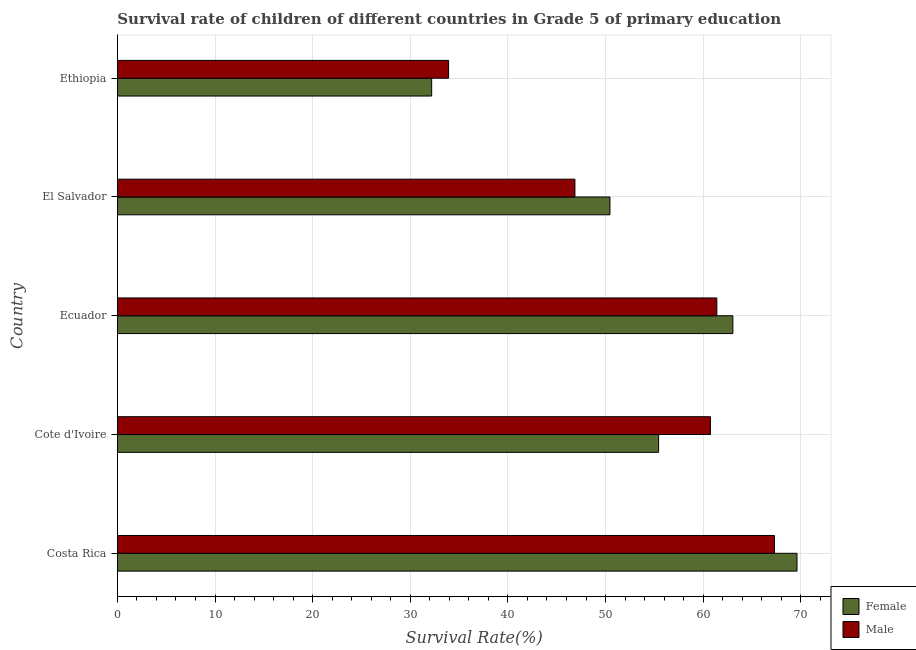How many groups of bars are there?
Provide a short and direct response. 5. How many bars are there on the 5th tick from the bottom?
Offer a very short reply. 2. What is the label of the 5th group of bars from the top?
Make the answer very short. Costa Rica. What is the survival rate of female students in primary education in Ecuador?
Make the answer very short. 63.04. Across all countries, what is the maximum survival rate of female students in primary education?
Provide a short and direct response. 69.61. Across all countries, what is the minimum survival rate of female students in primary education?
Make the answer very short. 32.19. In which country was the survival rate of male students in primary education minimum?
Offer a very short reply. Ethiopia. What is the total survival rate of male students in primary education in the graph?
Offer a terse response. 270.22. What is the difference between the survival rate of female students in primary education in Costa Rica and that in Ecuador?
Your answer should be compact. 6.57. What is the difference between the survival rate of male students in primary education in Ethiopia and the survival rate of female students in primary education in Cote d'Ivoire?
Your answer should be compact. -21.51. What is the average survival rate of male students in primary education per country?
Ensure brevity in your answer.  54.04. What is the difference between the survival rate of female students in primary education and survival rate of male students in primary education in Cote d'Ivoire?
Offer a terse response. -5.31. In how many countries, is the survival rate of male students in primary education greater than 28 %?
Offer a very short reply. 5. What is the ratio of the survival rate of male students in primary education in Ecuador to that in El Salvador?
Ensure brevity in your answer.  1.31. What is the difference between the highest and the second highest survival rate of male students in primary education?
Make the answer very short. 5.91. What is the difference between the highest and the lowest survival rate of male students in primary education?
Your answer should be compact. 33.38. In how many countries, is the survival rate of female students in primary education greater than the average survival rate of female students in primary education taken over all countries?
Make the answer very short. 3. Is the sum of the survival rate of female students in primary education in Cote d'Ivoire and El Salvador greater than the maximum survival rate of male students in primary education across all countries?
Give a very brief answer. Yes. What does the 2nd bar from the top in Ethiopia represents?
Ensure brevity in your answer.  Female. What does the 2nd bar from the bottom in Costa Rica represents?
Offer a very short reply. Male. How many bars are there?
Ensure brevity in your answer.  10. Are all the bars in the graph horizontal?
Provide a short and direct response. Yes. How many countries are there in the graph?
Provide a short and direct response. 5. Does the graph contain any zero values?
Provide a short and direct response. No. Does the graph contain grids?
Keep it short and to the point. Yes. How many legend labels are there?
Your answer should be very brief. 2. What is the title of the graph?
Your answer should be compact. Survival rate of children of different countries in Grade 5 of primary education. What is the label or title of the X-axis?
Provide a succinct answer. Survival Rate(%). What is the Survival Rate(%) in Female in Costa Rica?
Ensure brevity in your answer.  69.61. What is the Survival Rate(%) in Male in Costa Rica?
Make the answer very short. 67.3. What is the Survival Rate(%) of Female in Cote d'Ivoire?
Give a very brief answer. 55.43. What is the Survival Rate(%) in Male in Cote d'Ivoire?
Provide a short and direct response. 60.74. What is the Survival Rate(%) in Female in Ecuador?
Ensure brevity in your answer.  63.04. What is the Survival Rate(%) in Male in Ecuador?
Your response must be concise. 61.39. What is the Survival Rate(%) in Female in El Salvador?
Make the answer very short. 50.45. What is the Survival Rate(%) of Male in El Salvador?
Your response must be concise. 46.86. What is the Survival Rate(%) in Female in Ethiopia?
Keep it short and to the point. 32.19. What is the Survival Rate(%) in Male in Ethiopia?
Your answer should be very brief. 33.92. Across all countries, what is the maximum Survival Rate(%) in Female?
Your response must be concise. 69.61. Across all countries, what is the maximum Survival Rate(%) in Male?
Keep it short and to the point. 67.3. Across all countries, what is the minimum Survival Rate(%) of Female?
Your answer should be compact. 32.19. Across all countries, what is the minimum Survival Rate(%) of Male?
Your answer should be compact. 33.92. What is the total Survival Rate(%) in Female in the graph?
Your answer should be very brief. 270.72. What is the total Survival Rate(%) in Male in the graph?
Your answer should be very brief. 270.22. What is the difference between the Survival Rate(%) in Female in Costa Rica and that in Cote d'Ivoire?
Keep it short and to the point. 14.17. What is the difference between the Survival Rate(%) of Male in Costa Rica and that in Cote d'Ivoire?
Give a very brief answer. 6.56. What is the difference between the Survival Rate(%) in Female in Costa Rica and that in Ecuador?
Your answer should be compact. 6.57. What is the difference between the Survival Rate(%) in Male in Costa Rica and that in Ecuador?
Ensure brevity in your answer.  5.91. What is the difference between the Survival Rate(%) of Female in Costa Rica and that in El Salvador?
Offer a very short reply. 19.16. What is the difference between the Survival Rate(%) in Male in Costa Rica and that in El Salvador?
Ensure brevity in your answer.  20.44. What is the difference between the Survival Rate(%) in Female in Costa Rica and that in Ethiopia?
Your answer should be compact. 37.42. What is the difference between the Survival Rate(%) of Male in Costa Rica and that in Ethiopia?
Provide a succinct answer. 33.38. What is the difference between the Survival Rate(%) in Female in Cote d'Ivoire and that in Ecuador?
Provide a short and direct response. -7.61. What is the difference between the Survival Rate(%) in Male in Cote d'Ivoire and that in Ecuador?
Keep it short and to the point. -0.66. What is the difference between the Survival Rate(%) in Female in Cote d'Ivoire and that in El Salvador?
Make the answer very short. 4.98. What is the difference between the Survival Rate(%) of Male in Cote d'Ivoire and that in El Salvador?
Ensure brevity in your answer.  13.88. What is the difference between the Survival Rate(%) of Female in Cote d'Ivoire and that in Ethiopia?
Ensure brevity in your answer.  23.24. What is the difference between the Survival Rate(%) of Male in Cote d'Ivoire and that in Ethiopia?
Your response must be concise. 26.82. What is the difference between the Survival Rate(%) of Female in Ecuador and that in El Salvador?
Provide a short and direct response. 12.59. What is the difference between the Survival Rate(%) in Male in Ecuador and that in El Salvador?
Ensure brevity in your answer.  14.53. What is the difference between the Survival Rate(%) of Female in Ecuador and that in Ethiopia?
Provide a succinct answer. 30.85. What is the difference between the Survival Rate(%) in Male in Ecuador and that in Ethiopia?
Your answer should be compact. 27.47. What is the difference between the Survival Rate(%) in Female in El Salvador and that in Ethiopia?
Provide a short and direct response. 18.26. What is the difference between the Survival Rate(%) in Male in El Salvador and that in Ethiopia?
Make the answer very short. 12.94. What is the difference between the Survival Rate(%) of Female in Costa Rica and the Survival Rate(%) of Male in Cote d'Ivoire?
Make the answer very short. 8.87. What is the difference between the Survival Rate(%) in Female in Costa Rica and the Survival Rate(%) in Male in Ecuador?
Your answer should be compact. 8.21. What is the difference between the Survival Rate(%) in Female in Costa Rica and the Survival Rate(%) in Male in El Salvador?
Offer a very short reply. 22.75. What is the difference between the Survival Rate(%) of Female in Costa Rica and the Survival Rate(%) of Male in Ethiopia?
Offer a very short reply. 35.68. What is the difference between the Survival Rate(%) of Female in Cote d'Ivoire and the Survival Rate(%) of Male in Ecuador?
Your response must be concise. -5.96. What is the difference between the Survival Rate(%) in Female in Cote d'Ivoire and the Survival Rate(%) in Male in El Salvador?
Keep it short and to the point. 8.57. What is the difference between the Survival Rate(%) of Female in Cote d'Ivoire and the Survival Rate(%) of Male in Ethiopia?
Your answer should be compact. 21.51. What is the difference between the Survival Rate(%) in Female in Ecuador and the Survival Rate(%) in Male in El Salvador?
Make the answer very short. 16.18. What is the difference between the Survival Rate(%) of Female in Ecuador and the Survival Rate(%) of Male in Ethiopia?
Make the answer very short. 29.12. What is the difference between the Survival Rate(%) in Female in El Salvador and the Survival Rate(%) in Male in Ethiopia?
Offer a very short reply. 16.53. What is the average Survival Rate(%) in Female per country?
Provide a short and direct response. 54.14. What is the average Survival Rate(%) in Male per country?
Give a very brief answer. 54.04. What is the difference between the Survival Rate(%) of Female and Survival Rate(%) of Male in Costa Rica?
Offer a terse response. 2.31. What is the difference between the Survival Rate(%) of Female and Survival Rate(%) of Male in Cote d'Ivoire?
Your response must be concise. -5.31. What is the difference between the Survival Rate(%) in Female and Survival Rate(%) in Male in Ecuador?
Make the answer very short. 1.64. What is the difference between the Survival Rate(%) in Female and Survival Rate(%) in Male in El Salvador?
Provide a short and direct response. 3.59. What is the difference between the Survival Rate(%) in Female and Survival Rate(%) in Male in Ethiopia?
Give a very brief answer. -1.73. What is the ratio of the Survival Rate(%) of Female in Costa Rica to that in Cote d'Ivoire?
Offer a terse response. 1.26. What is the ratio of the Survival Rate(%) in Male in Costa Rica to that in Cote d'Ivoire?
Keep it short and to the point. 1.11. What is the ratio of the Survival Rate(%) in Female in Costa Rica to that in Ecuador?
Your response must be concise. 1.1. What is the ratio of the Survival Rate(%) of Male in Costa Rica to that in Ecuador?
Provide a succinct answer. 1.1. What is the ratio of the Survival Rate(%) in Female in Costa Rica to that in El Salvador?
Make the answer very short. 1.38. What is the ratio of the Survival Rate(%) in Male in Costa Rica to that in El Salvador?
Your answer should be compact. 1.44. What is the ratio of the Survival Rate(%) of Female in Costa Rica to that in Ethiopia?
Provide a short and direct response. 2.16. What is the ratio of the Survival Rate(%) in Male in Costa Rica to that in Ethiopia?
Give a very brief answer. 1.98. What is the ratio of the Survival Rate(%) in Female in Cote d'Ivoire to that in Ecuador?
Ensure brevity in your answer.  0.88. What is the ratio of the Survival Rate(%) in Male in Cote d'Ivoire to that in Ecuador?
Offer a very short reply. 0.99. What is the ratio of the Survival Rate(%) in Female in Cote d'Ivoire to that in El Salvador?
Your response must be concise. 1.1. What is the ratio of the Survival Rate(%) of Male in Cote d'Ivoire to that in El Salvador?
Provide a succinct answer. 1.3. What is the ratio of the Survival Rate(%) in Female in Cote d'Ivoire to that in Ethiopia?
Your answer should be compact. 1.72. What is the ratio of the Survival Rate(%) of Male in Cote d'Ivoire to that in Ethiopia?
Your response must be concise. 1.79. What is the ratio of the Survival Rate(%) of Female in Ecuador to that in El Salvador?
Your answer should be very brief. 1.25. What is the ratio of the Survival Rate(%) of Male in Ecuador to that in El Salvador?
Keep it short and to the point. 1.31. What is the ratio of the Survival Rate(%) of Female in Ecuador to that in Ethiopia?
Offer a very short reply. 1.96. What is the ratio of the Survival Rate(%) of Male in Ecuador to that in Ethiopia?
Offer a very short reply. 1.81. What is the ratio of the Survival Rate(%) in Female in El Salvador to that in Ethiopia?
Your answer should be very brief. 1.57. What is the ratio of the Survival Rate(%) of Male in El Salvador to that in Ethiopia?
Offer a very short reply. 1.38. What is the difference between the highest and the second highest Survival Rate(%) of Female?
Provide a succinct answer. 6.57. What is the difference between the highest and the second highest Survival Rate(%) of Male?
Offer a terse response. 5.91. What is the difference between the highest and the lowest Survival Rate(%) of Female?
Provide a succinct answer. 37.42. What is the difference between the highest and the lowest Survival Rate(%) of Male?
Provide a short and direct response. 33.38. 